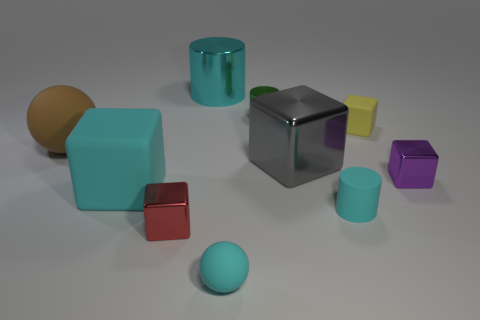There is a metallic object that is both on the left side of the cyan sphere and in front of the large cyan metallic cylinder; what size is it?
Keep it short and to the point. Small. How many brown things are made of the same material as the small cyan cylinder?
Provide a short and direct response. 1. How many cubes are either gray metal things or tiny green metallic things?
Offer a very short reply. 1. What size is the brown sphere that is behind the tiny cube to the left of the rubber sphere that is in front of the tiny rubber cylinder?
Keep it short and to the point. Large. What color is the cylinder that is both on the right side of the small cyan sphere and behind the tiny yellow rubber thing?
Keep it short and to the point. Green. Is the size of the purple object the same as the shiny cylinder that is behind the green cylinder?
Your answer should be compact. No. There is another matte object that is the same shape as the large brown object; what color is it?
Your response must be concise. Cyan. Is the size of the red object the same as the yellow matte block?
Ensure brevity in your answer.  Yes. How many other objects are the same size as the yellow rubber object?
Ensure brevity in your answer.  5. How many things are either matte objects right of the small cyan ball or things that are behind the large brown rubber sphere?
Your response must be concise. 4. 